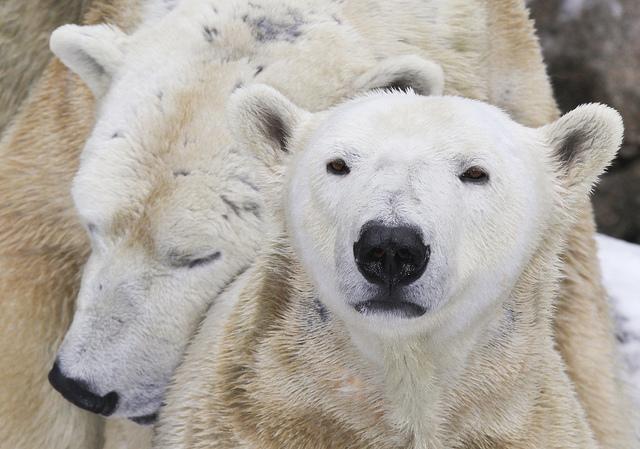How many bears are there?
Give a very brief answer. 2. How many bears are in the photo?
Give a very brief answer. 2. 